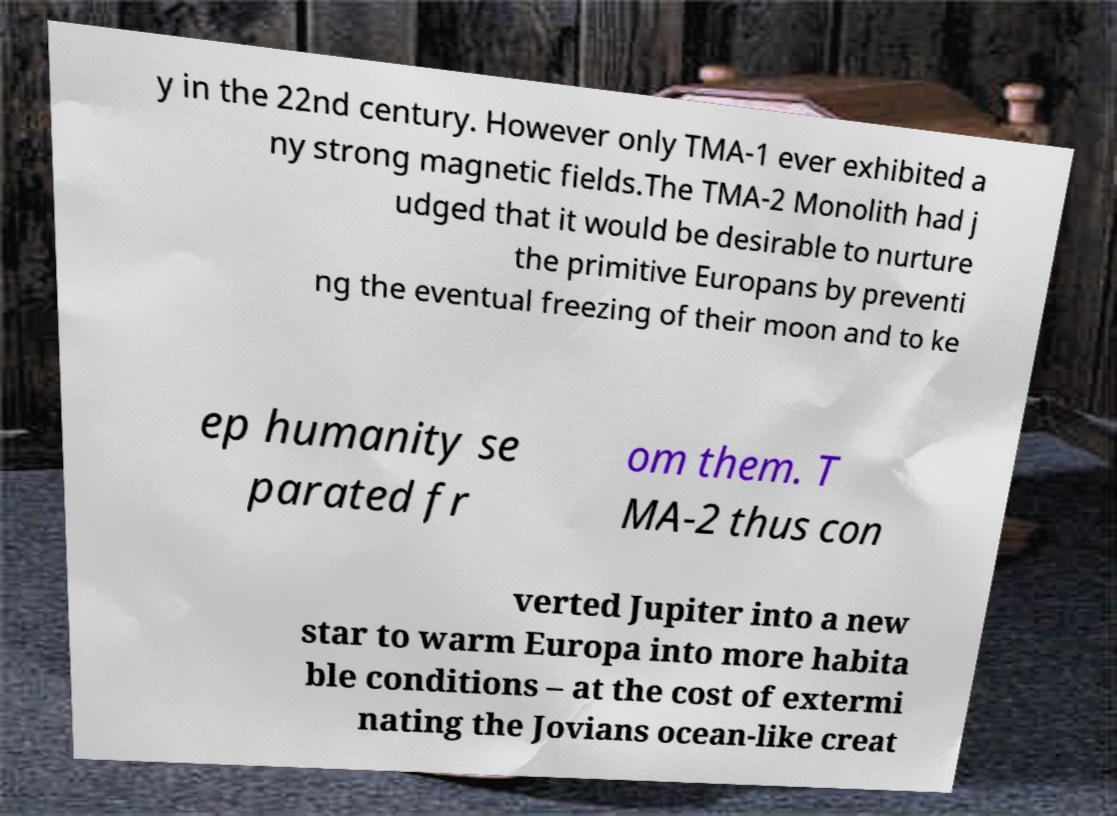Can you accurately transcribe the text from the provided image for me? y in the 22nd century. However only TMA-1 ever exhibited a ny strong magnetic fields.The TMA-2 Monolith had j udged that it would be desirable to nurture the primitive Europans by preventi ng the eventual freezing of their moon and to ke ep humanity se parated fr om them. T MA-2 thus con verted Jupiter into a new star to warm Europa into more habita ble conditions – at the cost of extermi nating the Jovians ocean-like creat 